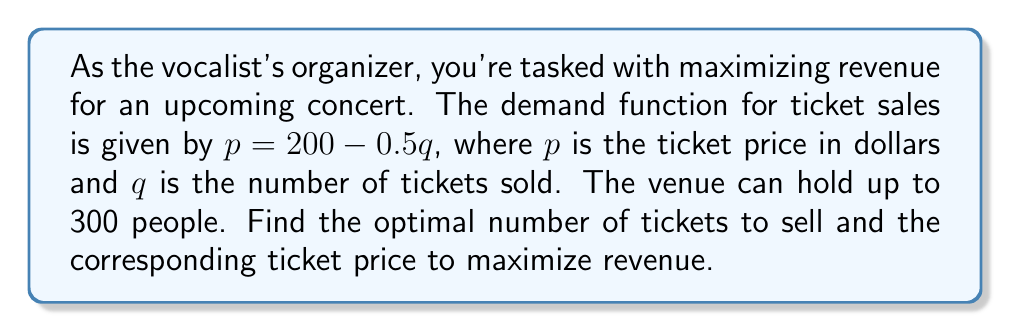Give your solution to this math problem. 1. The revenue function $R(q)$ is given by price times quantity:
   $R(q) = pq = (200 - 0.5q)q = 200q - 0.5q^2$

2. To find the maximum revenue point, we need to find the derivative of $R(q)$ and set it equal to zero:
   $\frac{dR}{dq} = 200 - q$

3. Set $\frac{dR}{dq} = 0$ and solve for $q$:
   $200 - q = 0$
   $q = 200$

4. The second derivative is negative ($\frac{d^2R}{dq^2} = -1$), confirming this is a maximum point.

5. Check if this quantity is within the venue capacity (300):
   Since 200 < 300, this solution is valid.

6. Calculate the optimal ticket price:
   $p = 200 - 0.5(200) = 100$

7. Calculate the maximum revenue:
   $R_{max} = 100 \times 200 = 20,000$
Answer: Sell 200 tickets at $100 each for maximum revenue of $20,000. 